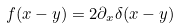<formula> <loc_0><loc_0><loc_500><loc_500>f ( x - y ) = 2 \partial _ { x } \delta ( x - y )</formula> 